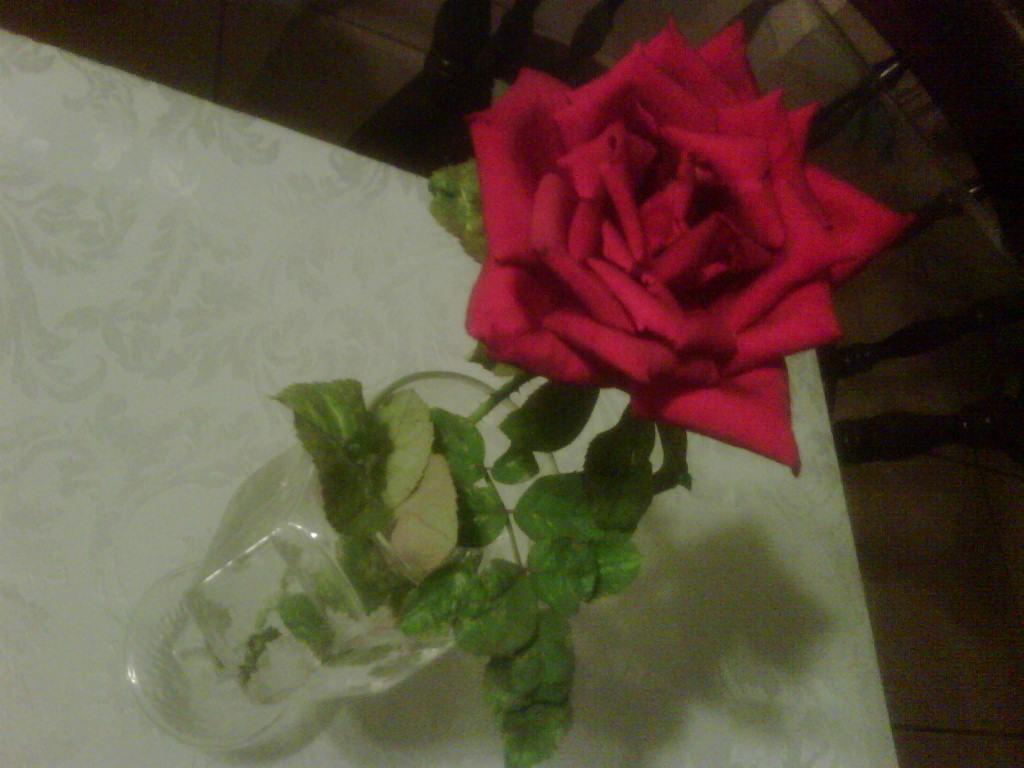Can you describe this image briefly? In the image there is a glass filled with water and a rose flower is kept in the water and the glass is placed on the table, beside the table there is a chair. 